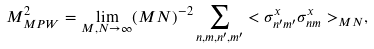<formula> <loc_0><loc_0><loc_500><loc_500>M _ { M P W } ^ { 2 } = \lim _ { M , N \rightarrow \infty } ( M N ) ^ { - 2 } \sum _ { n , m , n ^ { \prime } , m ^ { \prime } } < \sigma _ { n ^ { \prime } m ^ { \prime } } ^ { x } \sigma _ { n m } ^ { x } > _ { M N } ,</formula> 